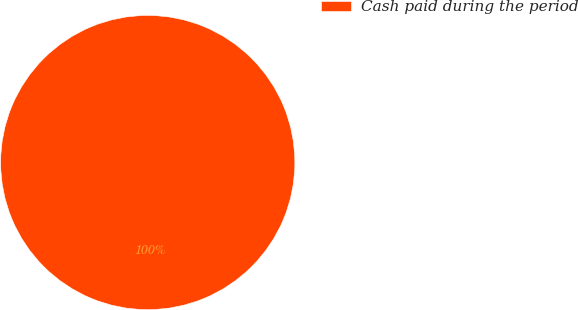<chart> <loc_0><loc_0><loc_500><loc_500><pie_chart><fcel>Cash paid during the period<nl><fcel>100.0%<nl></chart> 